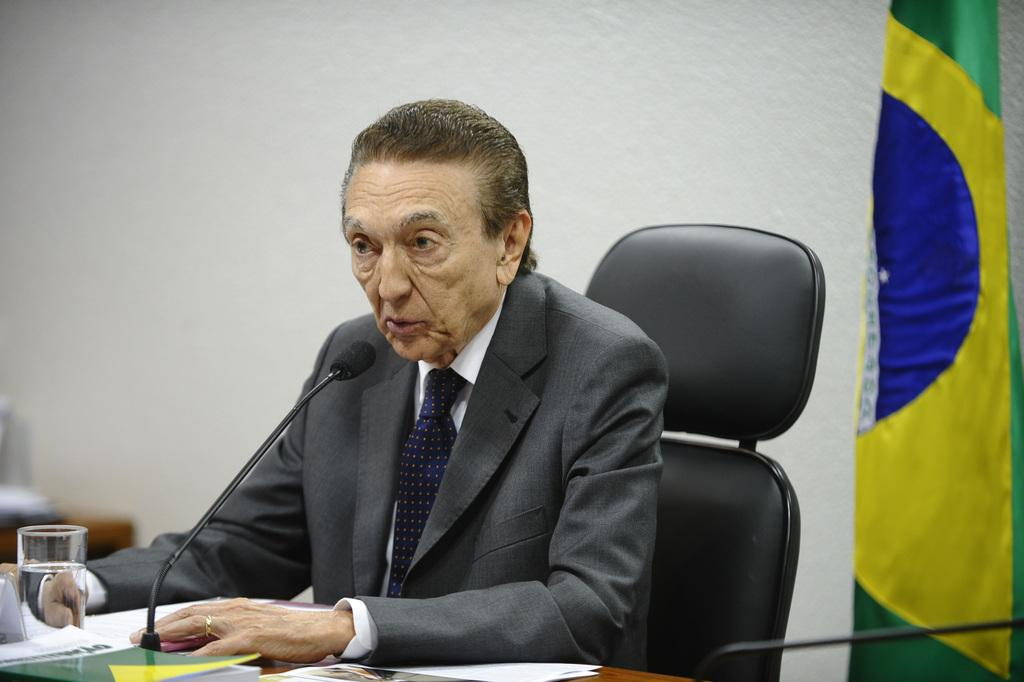What is the man in the image doing? The man is sitting on a chair in the image. What is in front of the man? There is a microphone in front of the man. What can be seen on the table? There is a glass on the table, and there are objects on the table. What is visible at the back of the scene? There is a wall at the back of the scene. Can you see any feathers floating in the air in the image? No, there are no feathers visible in the image. 